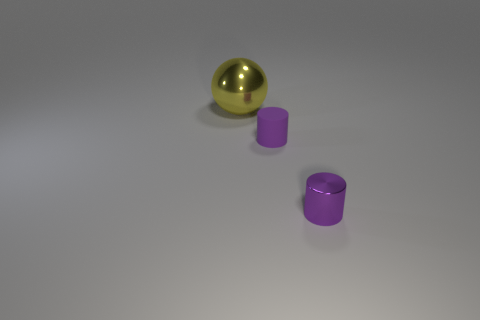Subtract all balls. How many objects are left? 2 Add 2 tiny blue cubes. How many objects exist? 5 Subtract 0 cyan spheres. How many objects are left? 3 Subtract all blue cubes. Subtract all purple metal cylinders. How many objects are left? 2 Add 3 yellow metallic objects. How many yellow metallic objects are left? 4 Add 3 big yellow balls. How many big yellow balls exist? 4 